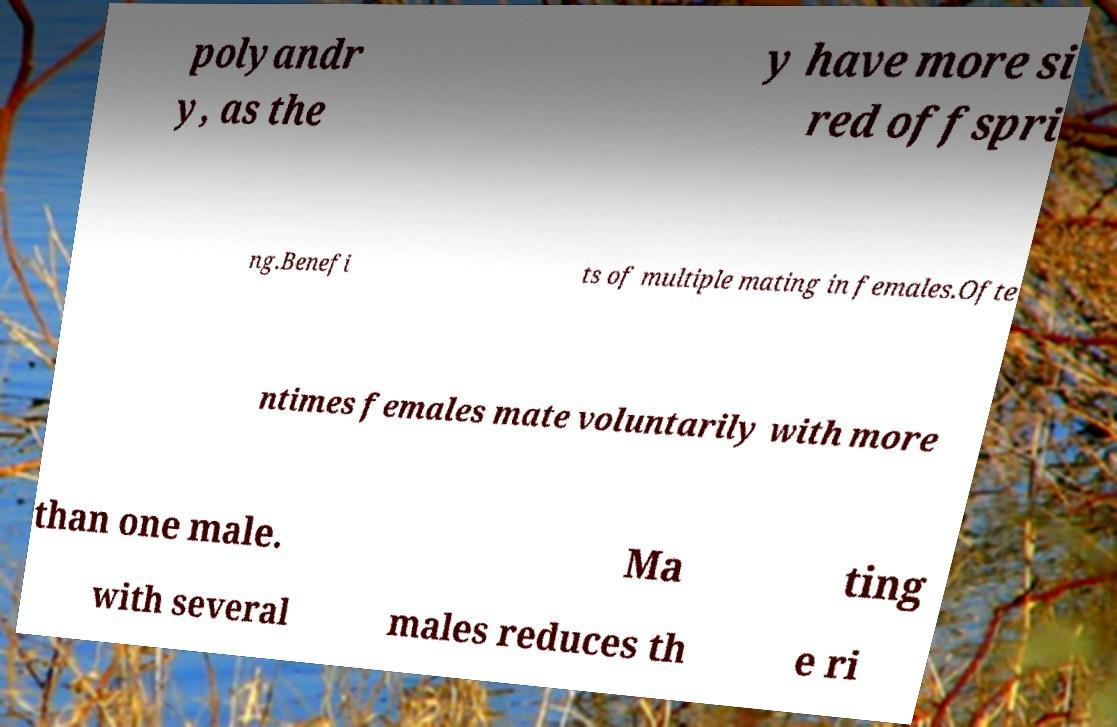Can you accurately transcribe the text from the provided image for me? polyandr y, as the y have more si red offspri ng.Benefi ts of multiple mating in females.Ofte ntimes females mate voluntarily with more than one male. Ma ting with several males reduces th e ri 